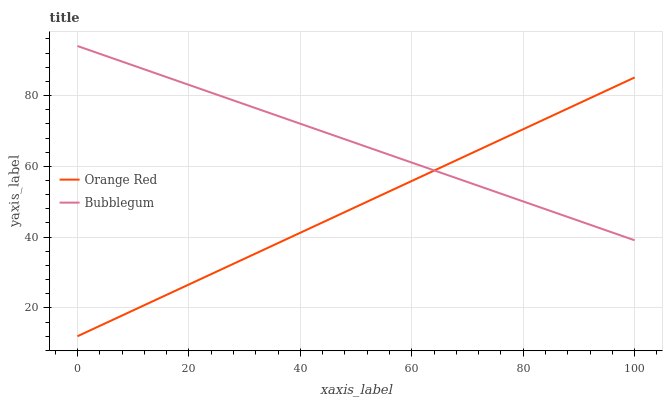Does Orange Red have the minimum area under the curve?
Answer yes or no. Yes. Does Bubblegum have the maximum area under the curve?
Answer yes or no. Yes. Does Bubblegum have the minimum area under the curve?
Answer yes or no. No. Is Bubblegum the smoothest?
Answer yes or no. Yes. Is Orange Red the roughest?
Answer yes or no. Yes. Is Bubblegum the roughest?
Answer yes or no. No. Does Orange Red have the lowest value?
Answer yes or no. Yes. Does Bubblegum have the lowest value?
Answer yes or no. No. Does Bubblegum have the highest value?
Answer yes or no. Yes. Does Bubblegum intersect Orange Red?
Answer yes or no. Yes. Is Bubblegum less than Orange Red?
Answer yes or no. No. Is Bubblegum greater than Orange Red?
Answer yes or no. No. 